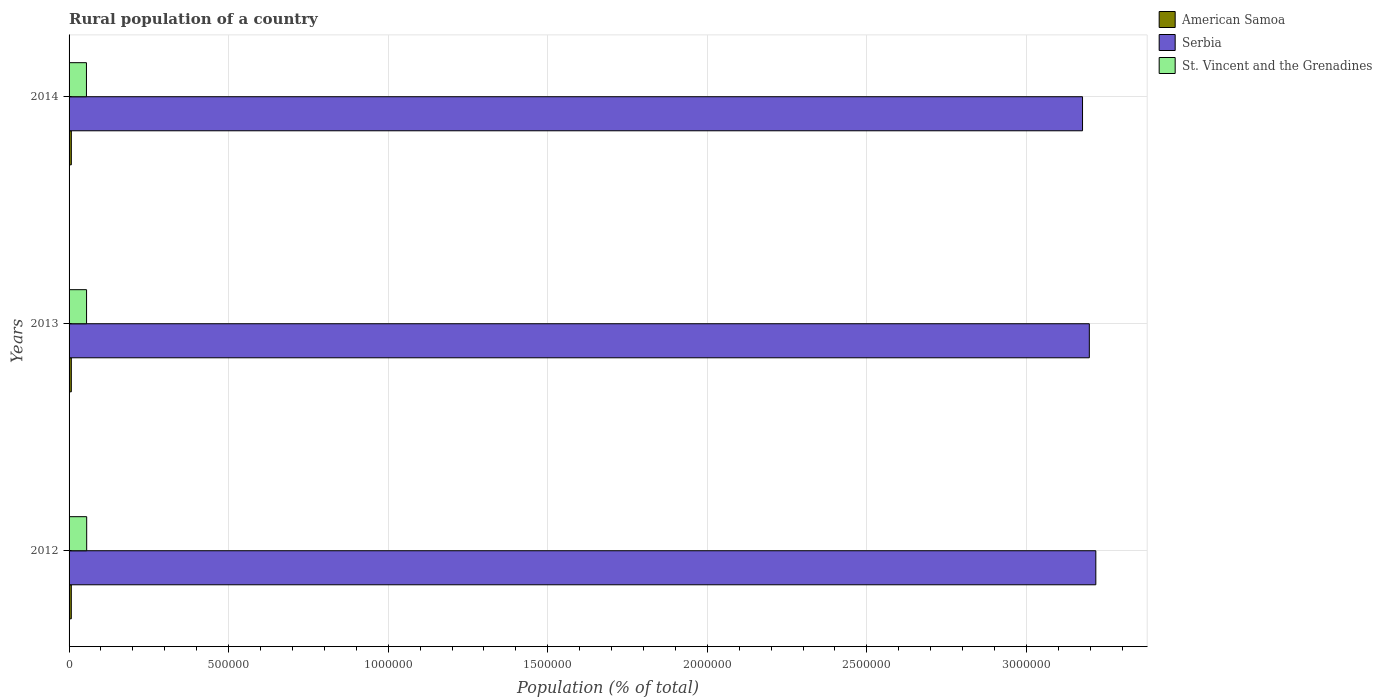How many different coloured bars are there?
Make the answer very short. 3. How many groups of bars are there?
Provide a succinct answer. 3. How many bars are there on the 3rd tick from the top?
Offer a terse response. 3. How many bars are there on the 1st tick from the bottom?
Your answer should be compact. 3. In how many cases, is the number of bars for a given year not equal to the number of legend labels?
Offer a terse response. 0. What is the rural population in St. Vincent and the Grenadines in 2014?
Your response must be concise. 5.45e+04. Across all years, what is the maximum rural population in American Samoa?
Your response must be concise. 7060. Across all years, what is the minimum rural population in St. Vincent and the Grenadines?
Give a very brief answer. 5.45e+04. What is the total rural population in American Samoa in the graph?
Provide a succinct answer. 2.10e+04. What is the difference between the rural population in Serbia in 2012 and that in 2014?
Offer a very short reply. 4.17e+04. What is the difference between the rural population in St. Vincent and the Grenadines in 2014 and the rural population in Serbia in 2013?
Keep it short and to the point. -3.14e+06. What is the average rural population in St. Vincent and the Grenadines per year?
Your answer should be compact. 5.48e+04. In the year 2013, what is the difference between the rural population in St. Vincent and the Grenadines and rural population in American Samoa?
Your response must be concise. 4.78e+04. In how many years, is the rural population in American Samoa greater than 2200000 %?
Your response must be concise. 0. What is the ratio of the rural population in American Samoa in 2012 to that in 2014?
Your response must be concise. 0.98. Is the rural population in St. Vincent and the Grenadines in 2012 less than that in 2013?
Your answer should be compact. No. What is the difference between the highest and the second highest rural population in Serbia?
Offer a terse response. 2.03e+04. What is the difference between the highest and the lowest rural population in American Samoa?
Make the answer very short. 109. In how many years, is the rural population in Serbia greater than the average rural population in Serbia taken over all years?
Your answer should be compact. 2. Is the sum of the rural population in St. Vincent and the Grenadines in 2012 and 2014 greater than the maximum rural population in Serbia across all years?
Give a very brief answer. No. What does the 2nd bar from the top in 2012 represents?
Your answer should be compact. Serbia. What does the 1st bar from the bottom in 2012 represents?
Your answer should be compact. American Samoa. Is it the case that in every year, the sum of the rural population in Serbia and rural population in St. Vincent and the Grenadines is greater than the rural population in American Samoa?
Give a very brief answer. Yes. How many bars are there?
Keep it short and to the point. 9. How many years are there in the graph?
Offer a terse response. 3. What is the difference between two consecutive major ticks on the X-axis?
Your answer should be very brief. 5.00e+05. Are the values on the major ticks of X-axis written in scientific E-notation?
Provide a succinct answer. No. Does the graph contain any zero values?
Provide a short and direct response. No. Where does the legend appear in the graph?
Your answer should be compact. Top right. What is the title of the graph?
Make the answer very short. Rural population of a country. Does "Spain" appear as one of the legend labels in the graph?
Provide a succinct answer. No. What is the label or title of the X-axis?
Offer a very short reply. Population (% of total). What is the Population (% of total) in American Samoa in 2012?
Give a very brief answer. 6951. What is the Population (% of total) of Serbia in 2012?
Keep it short and to the point. 3.22e+06. What is the Population (% of total) in St. Vincent and the Grenadines in 2012?
Give a very brief answer. 5.52e+04. What is the Population (% of total) of American Samoa in 2013?
Your answer should be compact. 7005. What is the Population (% of total) of Serbia in 2013?
Provide a short and direct response. 3.20e+06. What is the Population (% of total) of St. Vincent and the Grenadines in 2013?
Offer a very short reply. 5.48e+04. What is the Population (% of total) in American Samoa in 2014?
Make the answer very short. 7060. What is the Population (% of total) of Serbia in 2014?
Keep it short and to the point. 3.18e+06. What is the Population (% of total) in St. Vincent and the Grenadines in 2014?
Ensure brevity in your answer.  5.45e+04. Across all years, what is the maximum Population (% of total) in American Samoa?
Give a very brief answer. 7060. Across all years, what is the maximum Population (% of total) in Serbia?
Give a very brief answer. 3.22e+06. Across all years, what is the maximum Population (% of total) of St. Vincent and the Grenadines?
Provide a succinct answer. 5.52e+04. Across all years, what is the minimum Population (% of total) of American Samoa?
Make the answer very short. 6951. Across all years, what is the minimum Population (% of total) in Serbia?
Ensure brevity in your answer.  3.18e+06. Across all years, what is the minimum Population (% of total) in St. Vincent and the Grenadines?
Provide a succinct answer. 5.45e+04. What is the total Population (% of total) in American Samoa in the graph?
Your answer should be very brief. 2.10e+04. What is the total Population (% of total) in Serbia in the graph?
Provide a succinct answer. 9.59e+06. What is the total Population (% of total) of St. Vincent and the Grenadines in the graph?
Your answer should be compact. 1.65e+05. What is the difference between the Population (% of total) of American Samoa in 2012 and that in 2013?
Offer a terse response. -54. What is the difference between the Population (% of total) in Serbia in 2012 and that in 2013?
Your response must be concise. 2.03e+04. What is the difference between the Population (% of total) of St. Vincent and the Grenadines in 2012 and that in 2013?
Give a very brief answer. 389. What is the difference between the Population (% of total) of American Samoa in 2012 and that in 2014?
Offer a very short reply. -109. What is the difference between the Population (% of total) of Serbia in 2012 and that in 2014?
Offer a very short reply. 4.17e+04. What is the difference between the Population (% of total) of St. Vincent and the Grenadines in 2012 and that in 2014?
Keep it short and to the point. 758. What is the difference between the Population (% of total) of American Samoa in 2013 and that in 2014?
Provide a short and direct response. -55. What is the difference between the Population (% of total) in Serbia in 2013 and that in 2014?
Give a very brief answer. 2.13e+04. What is the difference between the Population (% of total) in St. Vincent and the Grenadines in 2013 and that in 2014?
Your response must be concise. 369. What is the difference between the Population (% of total) in American Samoa in 2012 and the Population (% of total) in Serbia in 2013?
Give a very brief answer. -3.19e+06. What is the difference between the Population (% of total) of American Samoa in 2012 and the Population (% of total) of St. Vincent and the Grenadines in 2013?
Ensure brevity in your answer.  -4.79e+04. What is the difference between the Population (% of total) of Serbia in 2012 and the Population (% of total) of St. Vincent and the Grenadines in 2013?
Provide a short and direct response. 3.16e+06. What is the difference between the Population (% of total) in American Samoa in 2012 and the Population (% of total) in Serbia in 2014?
Make the answer very short. -3.17e+06. What is the difference between the Population (% of total) of American Samoa in 2012 and the Population (% of total) of St. Vincent and the Grenadines in 2014?
Your answer should be compact. -4.75e+04. What is the difference between the Population (% of total) of Serbia in 2012 and the Population (% of total) of St. Vincent and the Grenadines in 2014?
Keep it short and to the point. 3.16e+06. What is the difference between the Population (% of total) of American Samoa in 2013 and the Population (% of total) of Serbia in 2014?
Provide a short and direct response. -3.17e+06. What is the difference between the Population (% of total) of American Samoa in 2013 and the Population (% of total) of St. Vincent and the Grenadines in 2014?
Give a very brief answer. -4.75e+04. What is the difference between the Population (% of total) in Serbia in 2013 and the Population (% of total) in St. Vincent and the Grenadines in 2014?
Provide a succinct answer. 3.14e+06. What is the average Population (% of total) in American Samoa per year?
Offer a very short reply. 7005.33. What is the average Population (% of total) of Serbia per year?
Provide a short and direct response. 3.20e+06. What is the average Population (% of total) in St. Vincent and the Grenadines per year?
Make the answer very short. 5.48e+04. In the year 2012, what is the difference between the Population (% of total) of American Samoa and Population (% of total) of Serbia?
Your answer should be very brief. -3.21e+06. In the year 2012, what is the difference between the Population (% of total) in American Samoa and Population (% of total) in St. Vincent and the Grenadines?
Ensure brevity in your answer.  -4.83e+04. In the year 2012, what is the difference between the Population (% of total) of Serbia and Population (% of total) of St. Vincent and the Grenadines?
Your answer should be compact. 3.16e+06. In the year 2013, what is the difference between the Population (% of total) of American Samoa and Population (% of total) of Serbia?
Provide a succinct answer. -3.19e+06. In the year 2013, what is the difference between the Population (% of total) in American Samoa and Population (% of total) in St. Vincent and the Grenadines?
Offer a very short reply. -4.78e+04. In the year 2013, what is the difference between the Population (% of total) of Serbia and Population (% of total) of St. Vincent and the Grenadines?
Give a very brief answer. 3.14e+06. In the year 2014, what is the difference between the Population (% of total) of American Samoa and Population (% of total) of Serbia?
Your response must be concise. -3.17e+06. In the year 2014, what is the difference between the Population (% of total) of American Samoa and Population (% of total) of St. Vincent and the Grenadines?
Ensure brevity in your answer.  -4.74e+04. In the year 2014, what is the difference between the Population (% of total) in Serbia and Population (% of total) in St. Vincent and the Grenadines?
Provide a short and direct response. 3.12e+06. What is the ratio of the Population (% of total) of American Samoa in 2012 to that in 2013?
Your response must be concise. 0.99. What is the ratio of the Population (% of total) of Serbia in 2012 to that in 2013?
Offer a terse response. 1.01. What is the ratio of the Population (% of total) of St. Vincent and the Grenadines in 2012 to that in 2013?
Offer a terse response. 1.01. What is the ratio of the Population (% of total) of American Samoa in 2012 to that in 2014?
Give a very brief answer. 0.98. What is the ratio of the Population (% of total) of Serbia in 2012 to that in 2014?
Ensure brevity in your answer.  1.01. What is the ratio of the Population (% of total) in St. Vincent and the Grenadines in 2012 to that in 2014?
Provide a succinct answer. 1.01. What is the ratio of the Population (% of total) in American Samoa in 2013 to that in 2014?
Your response must be concise. 0.99. What is the ratio of the Population (% of total) in Serbia in 2013 to that in 2014?
Offer a terse response. 1.01. What is the ratio of the Population (% of total) in St. Vincent and the Grenadines in 2013 to that in 2014?
Ensure brevity in your answer.  1.01. What is the difference between the highest and the second highest Population (% of total) of American Samoa?
Give a very brief answer. 55. What is the difference between the highest and the second highest Population (% of total) in Serbia?
Ensure brevity in your answer.  2.03e+04. What is the difference between the highest and the second highest Population (% of total) in St. Vincent and the Grenadines?
Your answer should be compact. 389. What is the difference between the highest and the lowest Population (% of total) of American Samoa?
Your response must be concise. 109. What is the difference between the highest and the lowest Population (% of total) in Serbia?
Your response must be concise. 4.17e+04. What is the difference between the highest and the lowest Population (% of total) in St. Vincent and the Grenadines?
Provide a short and direct response. 758. 